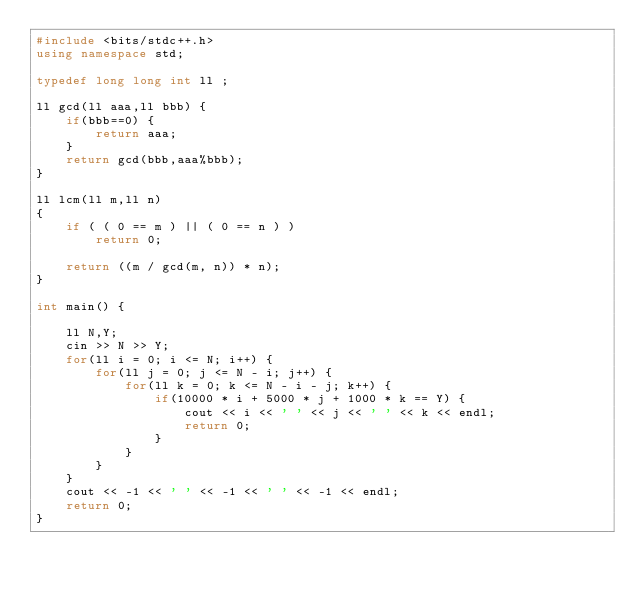Convert code to text. <code><loc_0><loc_0><loc_500><loc_500><_C++_>#include <bits/stdc++.h>
using namespace std;

typedef long long int ll ;

ll gcd(ll aaa,ll bbb) {
    if(bbb==0) {
        return aaa;
    }
    return gcd(bbb,aaa%bbb);
}

ll lcm(ll m,ll n)
{
    if ( ( 0 == m ) || ( 0 == n ) )
        return 0;

    return ((m / gcd(m, n)) * n);
}

int main() {

	ll N,Y;
	cin >> N >> Y;
	for(ll i = 0; i <= N; i++) {
		for(ll j = 0; j <= N - i; j++) {
			for(ll k = 0; k <= N - i - j; k++) {
				if(10000 * i + 5000 * j + 1000 * k == Y) {
					cout << i << ' ' << j << ' ' << k << endl;
					return 0;
				}
			}
		}
	}
	cout << -1 << ' ' << -1 << ' ' << -1 << endl;
	return 0;
}</code> 